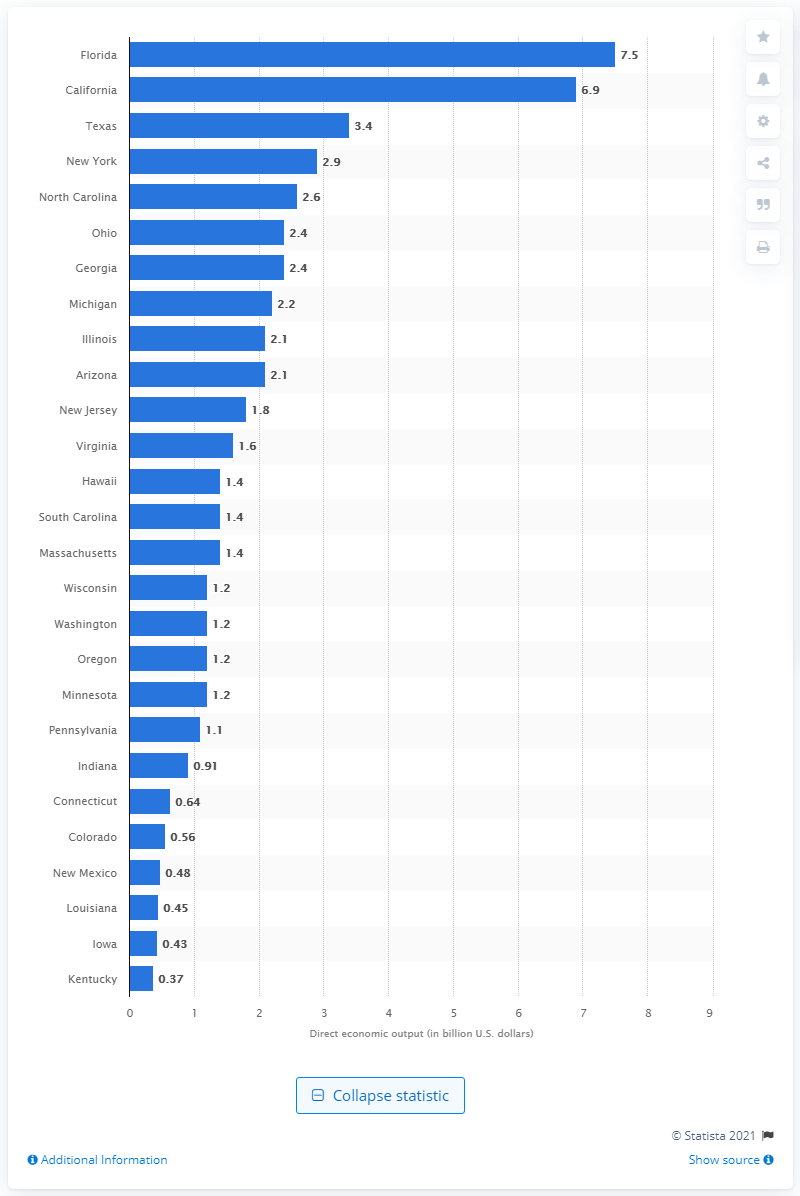Give some essential details in this illustration. In 2006, the direct economic output of the golf industry in New Mexico was approximately $0.48 billion. 